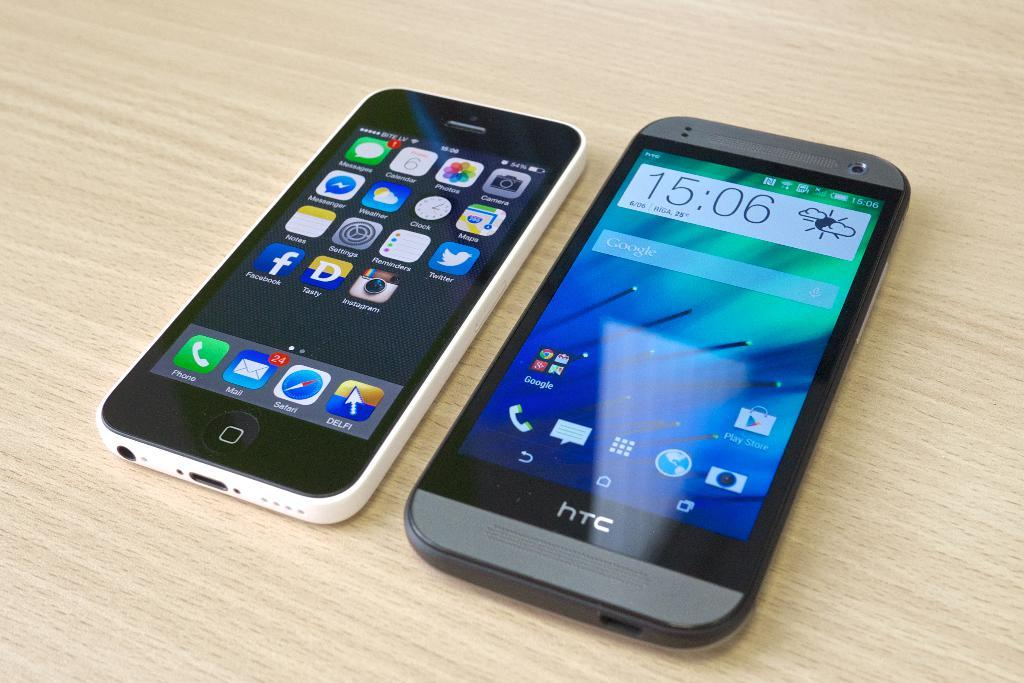<image>
Present a compact description of the photo's key features. An iPhone sits next to an htc phone that shows the time as 15:06. 